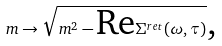Convert formula to latex. <formula><loc_0><loc_0><loc_500><loc_500>m \rightarrow \sqrt { m ^ { 2 } - \text {Re} \Sigma ^ { r e t } ( \omega , \tau ) } \text {,}</formula> 